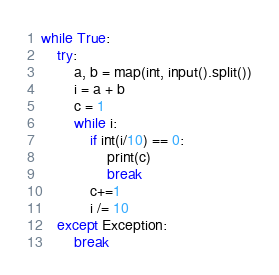Convert code to text. <code><loc_0><loc_0><loc_500><loc_500><_Python_>while True:
    try:
        a, b = map(int, input().split())
        i = a + b
        c = 1
        while i:
            if int(i/10) == 0:
                print(c)
                break
            c+=1
            i /= 10
    except Exception:
        break</code> 